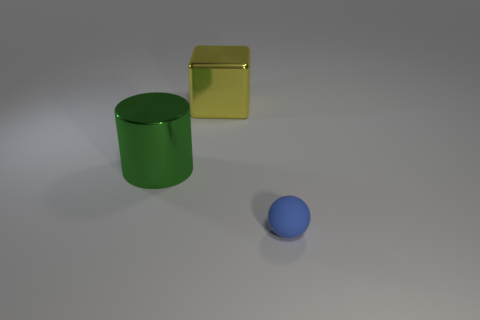Is there anything else that has the same material as the small ball?
Offer a very short reply. No. How many other things are there of the same shape as the blue rubber thing?
Provide a short and direct response. 0. How many purple things are either spheres or shiny cylinders?
Offer a very short reply. 0. There is a thing that is made of the same material as the large green cylinder; what color is it?
Keep it short and to the point. Yellow. Are the thing left of the yellow shiny object and the thing that is behind the green metallic cylinder made of the same material?
Offer a very short reply. Yes. What material is the object that is in front of the green cylinder?
Your response must be concise. Rubber. Are there any yellow cubes?
Give a very brief answer. Yes. There is a metallic cylinder; are there any green objects in front of it?
Your response must be concise. No. Do the big object that is in front of the big metallic cube and the big yellow object have the same material?
Your answer should be very brief. Yes. What shape is the green metal thing?
Make the answer very short. Cylinder. 